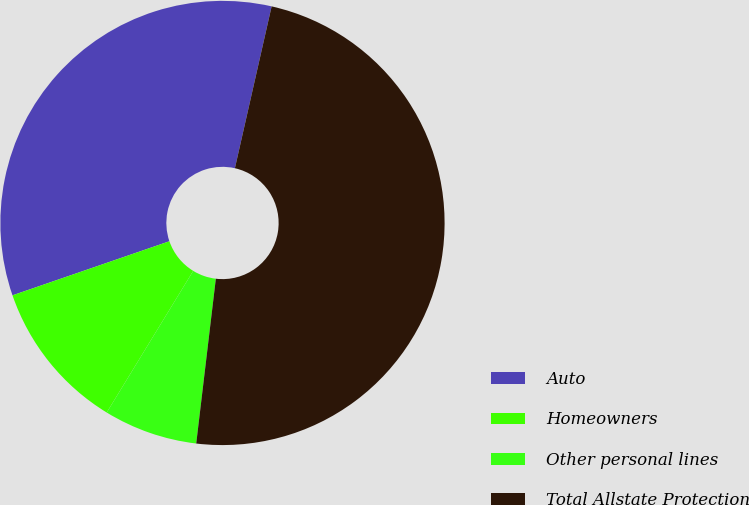<chart> <loc_0><loc_0><loc_500><loc_500><pie_chart><fcel>Auto<fcel>Homeowners<fcel>Other personal lines<fcel>Total Allstate Protection<nl><fcel>33.83%<fcel>10.99%<fcel>6.84%<fcel>48.33%<nl></chart> 